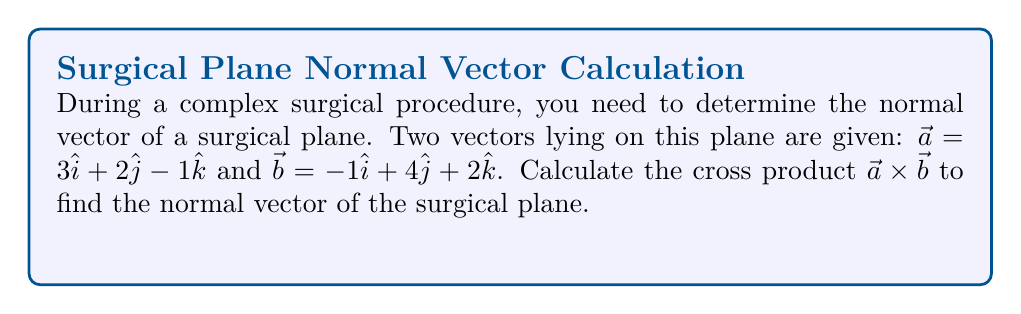Teach me how to tackle this problem. To find the normal vector of the surgical plane, we need to calculate the cross product of the two given vectors $\vec{a}$ and $\vec{b}$. The cross product $\vec{a} \times \vec{b}$ will give us a vector perpendicular to both $\vec{a}$ and $\vec{b}$, which is the normal vector we're looking for.

Let's calculate the cross product step by step:

1) The formula for the cross product of two vectors $\vec{a} = (a_1, a_2, a_3)$ and $\vec{b} = (b_1, b_2, b_3)$ is:

   $$\vec{a} \times \vec{b} = (a_2b_3 - a_3b_2)\hat{i} - (a_1b_3 - a_3b_1)\hat{j} + (a_1b_2 - a_2b_1)\hat{k}$$

2) We have $\vec{a} = 3\hat{i} + 2\hat{j} - 1\hat{k}$ and $\vec{b} = -1\hat{i} + 4\hat{j} + 2\hat{k}$

3) Let's calculate each component:

   For $\hat{i}$: $a_2b_3 - a_3b_2 = (2)(2) - (-1)(4) = 4 + 4 = 8$

   For $\hat{j}$: $-(a_1b_3 - a_3b_1) = -[(3)(2) - (-1)(-1)] = -(6 + 1) = -7$

   For $\hat{k}$: $a_1b_2 - a_2b_1 = (3)(4) - (2)(-1) = 12 + 2 = 14$

4) Therefore, the cross product is:

   $$\vec{a} \times \vec{b} = 8\hat{i} - 7\hat{j} + 14\hat{k}$$

This vector $(8, -7, 14)$ is perpendicular to both $\vec{a}$ and $\vec{b}$, and thus represents the normal vector to the surgical plane.
Answer: $8\hat{i} - 7\hat{j} + 14\hat{k}$ 